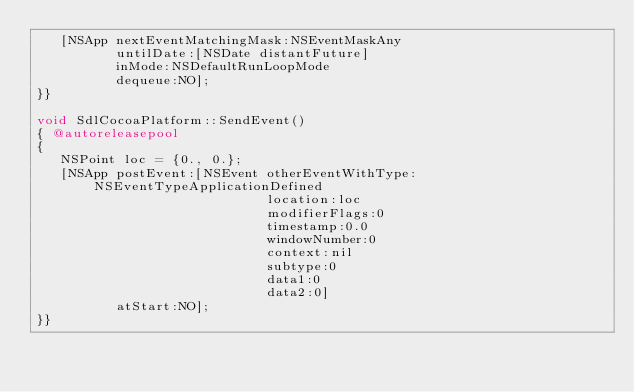<code> <loc_0><loc_0><loc_500><loc_500><_ObjectiveC_>   [NSApp nextEventMatchingMask:NSEventMaskAny
          untilDate:[NSDate distantFuture]
          inMode:NSDefaultRunLoopMode
          dequeue:NO];
}}

void SdlCocoaPlatform::SendEvent()
{ @autoreleasepool
{
   NSPoint loc = {0., 0.};
   [NSApp postEvent:[NSEvent otherEventWithType:NSEventTypeApplicationDefined
                             location:loc
                             modifierFlags:0
                             timestamp:0.0
                             windowNumber:0
                             context:nil
                             subtype:0
                             data1:0
                             data2:0]
          atStart:NO];
}}
</code> 